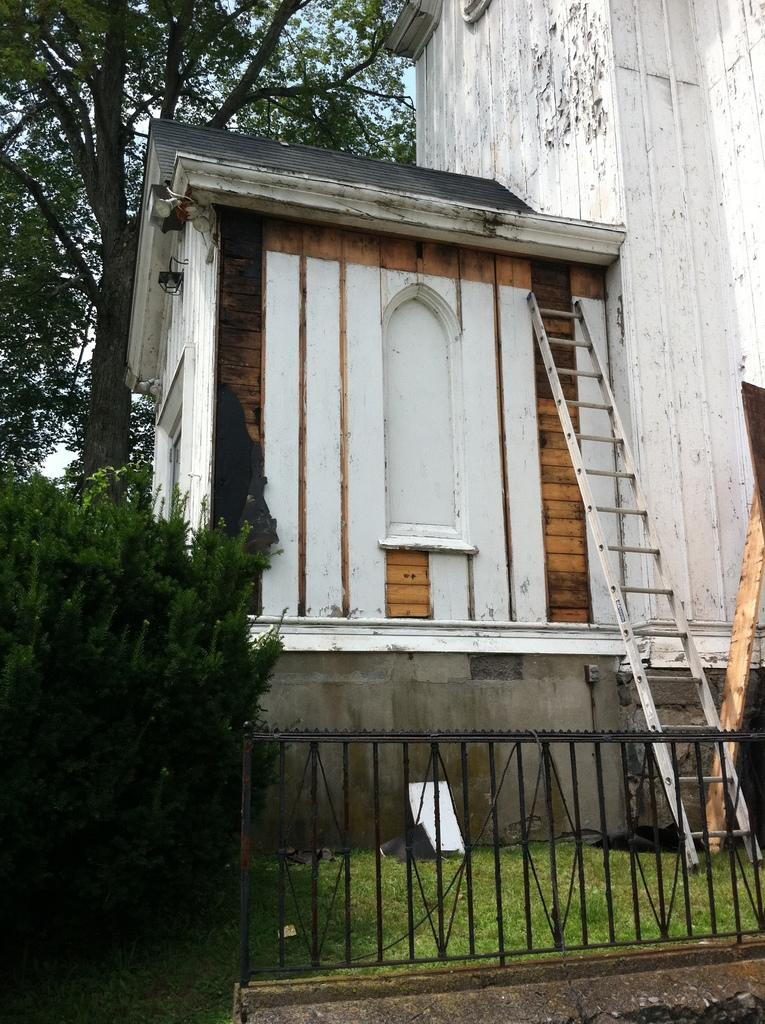What type of structure is visible in the image? There is a building in the image. What is the ladder used for in the image? The ladder is likely used for reaching higher areas, such as the roof of the building. What type of ground surface is present in the image? Grass is present in the image. What type of vegetation can be seen in the image? There are plants and a tree in the image. What is the wooden pole used for in the image? The wooden pole might be used for supporting a structure or as a marker. What part of the natural environment is visible in the image? The sky is visible in the image. How many cattle are grazing in the grass in the image? There are no cattle present in the image; it features a building, a ladder, grass, plants, a tree, a wooden pole, and the sky. What type of boot is hanging from the tree in the image? There is no boot hanging from the tree in the image; it only features a tree and other objects mentioned in the conversation. 